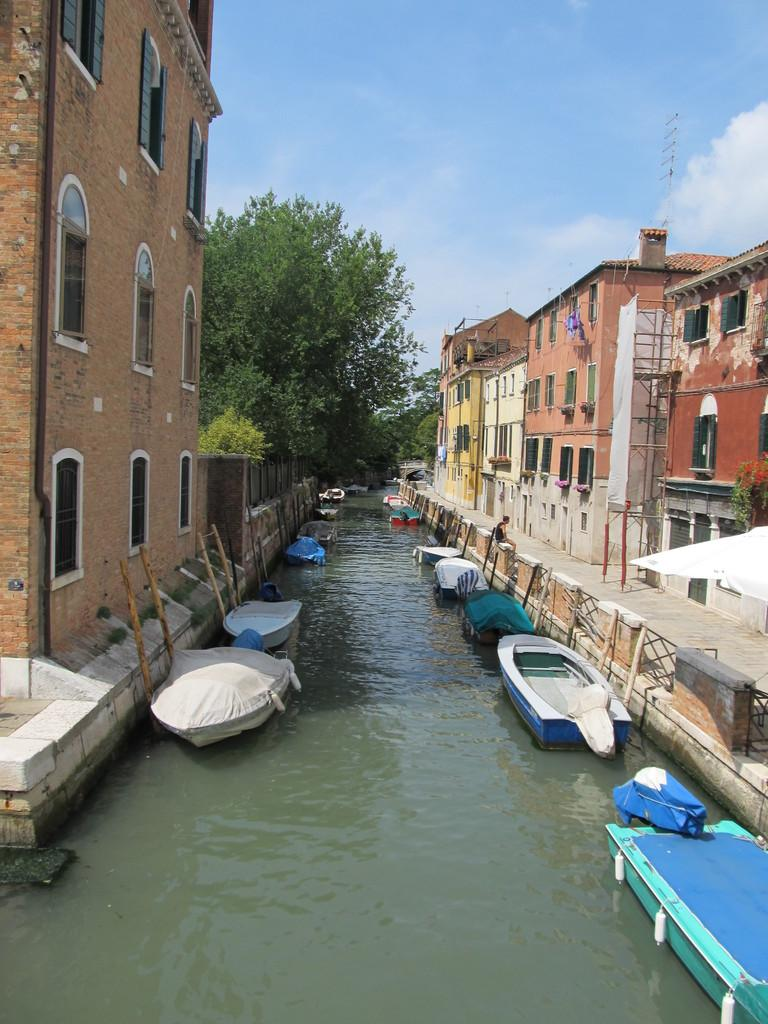What is the main subject in the center of the image? There are boats in the water in the center of the image. What can be seen in the background of the image? There are trees and buildings in the background of the image. What is visible in the sky at the top of the image? There are clouds visible in the sky at the top of the image. How much money is floating on the water next to the boats in the image? There is no money visible in the image; it only features boats in the water, trees and buildings in the background, and clouds in the sky. 